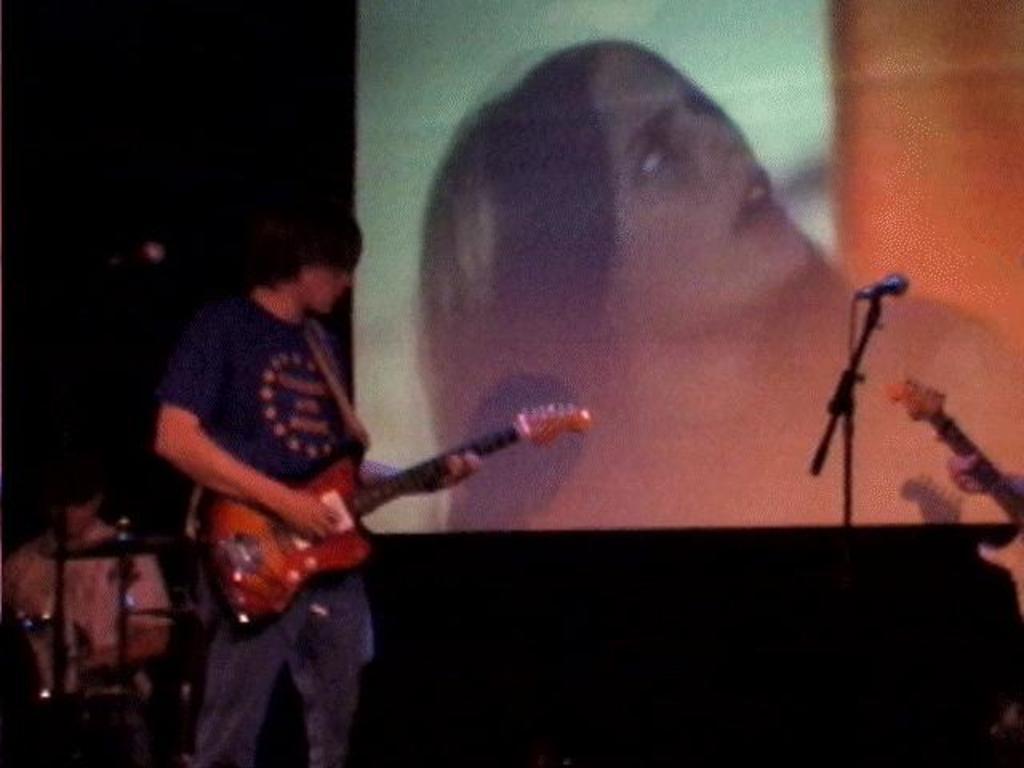Please provide a concise description of this image. In this image i can see a man holding guitar and playing at the back ground i can see a microphone and a screen. 